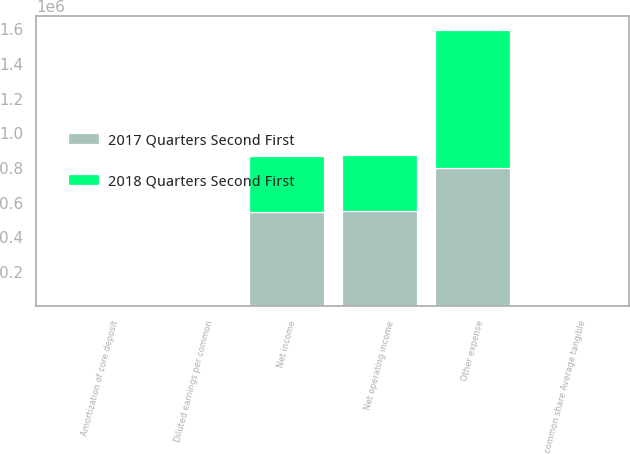Convert chart. <chart><loc_0><loc_0><loc_500><loc_500><stacked_bar_chart><ecel><fcel>Net income<fcel>Amortization of core deposit<fcel>Net operating income<fcel>Diluted earnings per common<fcel>common share Average tangible<fcel>Other expense<nl><fcel>2017 Quarters Second First<fcel>546219<fcel>5359<fcel>550169<fcel>3.76<fcel>3.79<fcel>802162<nl><fcel>2018 Quarters Second First<fcel>322403<fcel>7025<fcel>326664<fcel>2.01<fcel>2.04<fcel>795813<nl></chart> 